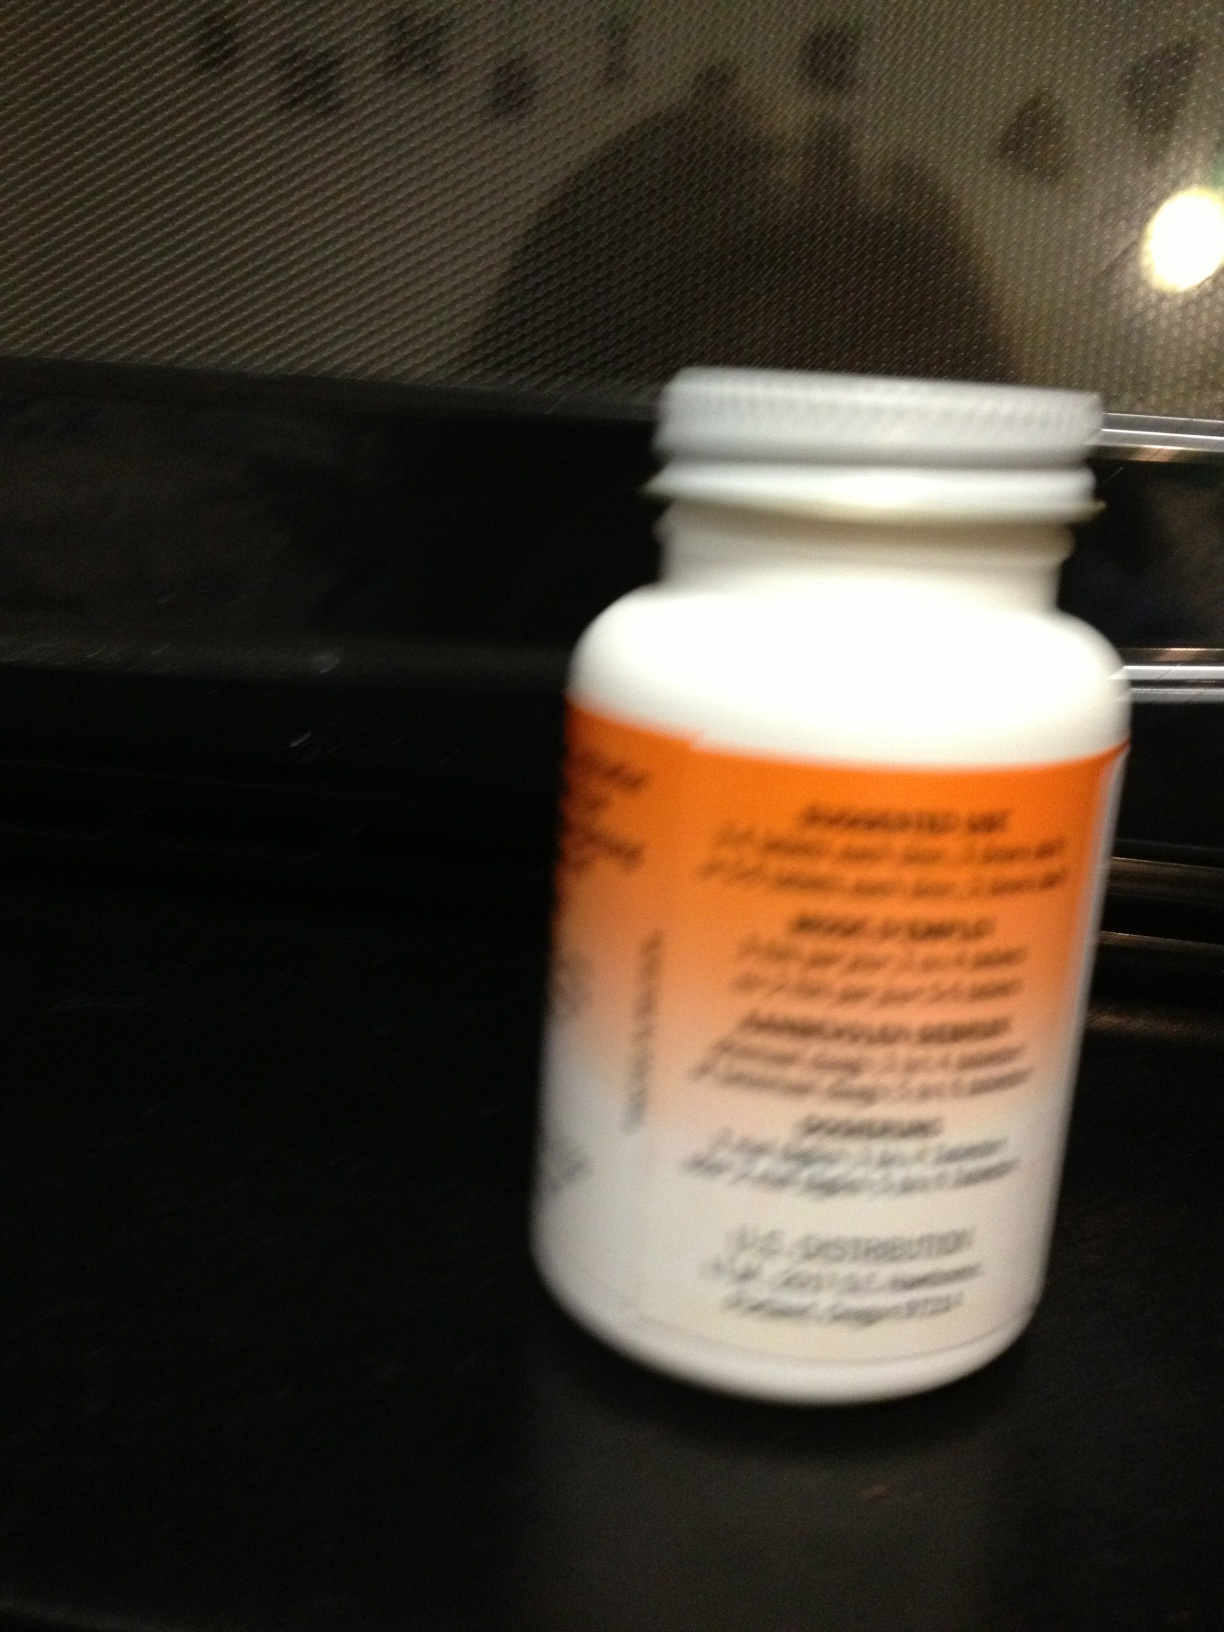Can you read the brand, dosage information, or any other things about this bottle? Due to the blurriness of the image, specific details like the brand or dosage information on the bottle label are not clearly visible. However, the bottle appears to be a standard prescription medicine container typically found in pharmacies, suggesting it might contain medication. Handling such bottles with care and consulting a pharmacist or healthcare provider for clarity is advisable when details are unclear. 